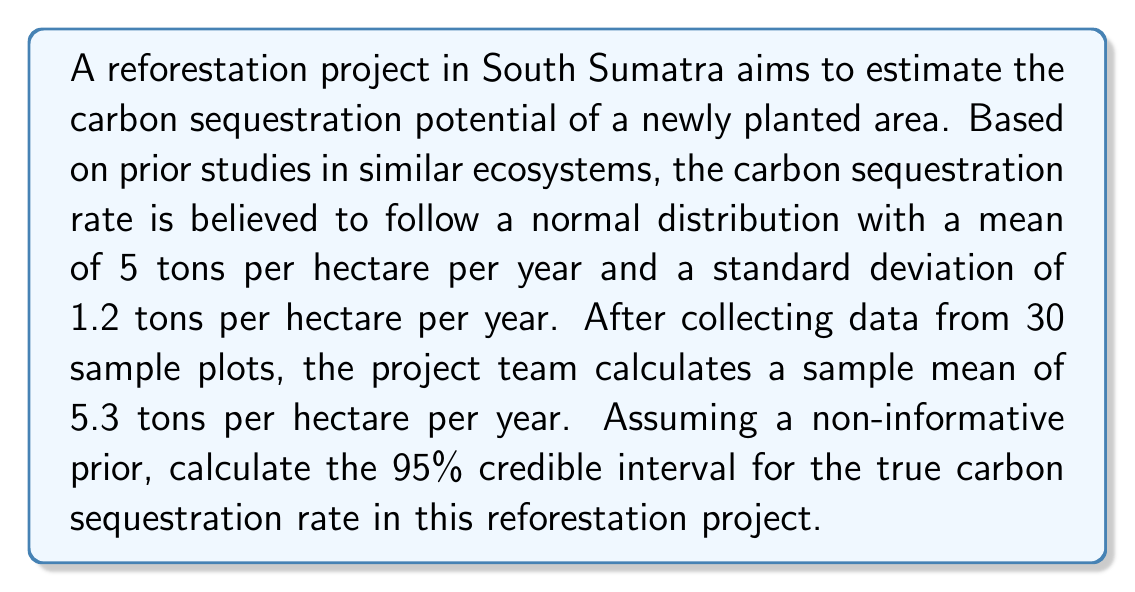Give your solution to this math problem. To solve this problem, we'll use Bayesian inference with a non-informative prior. The steps are as follows:

1. Define the prior distribution:
   Given the non-informative prior, we'll use the sample data to inform our posterior distribution.

2. Calculate the posterior distribution:
   The posterior distribution for the mean with a known variance follows a normal distribution:

   $$ \mu | x \sim N(\bar{x}, \frac{\sigma^2}{n}) $$

   Where:
   $\bar{x}$ is the sample mean (5.3 tons/ha/year)
   $\sigma$ is the known standard deviation (1.2 tons/ha/year)
   $n$ is the sample size (30)

3. Calculate the standard error of the posterior mean:
   $$ SE = \frac{\sigma}{\sqrt{n}} = \frac{1.2}{\sqrt{30}} = 0.219 $$

4. Determine the critical value for a 95% credible interval:
   For a 95% interval, we use the z-score of 1.96 (rounded to 2 decimal places).

5. Calculate the credible interval:
   Lower bound: $\bar{x} - 1.96 \times SE = 5.3 - 1.96 \times 0.219 = 4.87$ tons/ha/year
   Upper bound: $\bar{x} + 1.96 \times SE = 5.3 + 1.96 \times 0.219 = 5.73$ tons/ha/year

Therefore, the 95% credible interval for the true carbon sequestration rate is (4.87, 5.73) tons per hectare per year.
Answer: The 95% credible interval for the true carbon sequestration rate in the South Sumatra reforestation project is (4.87, 5.73) tons per hectare per year. 